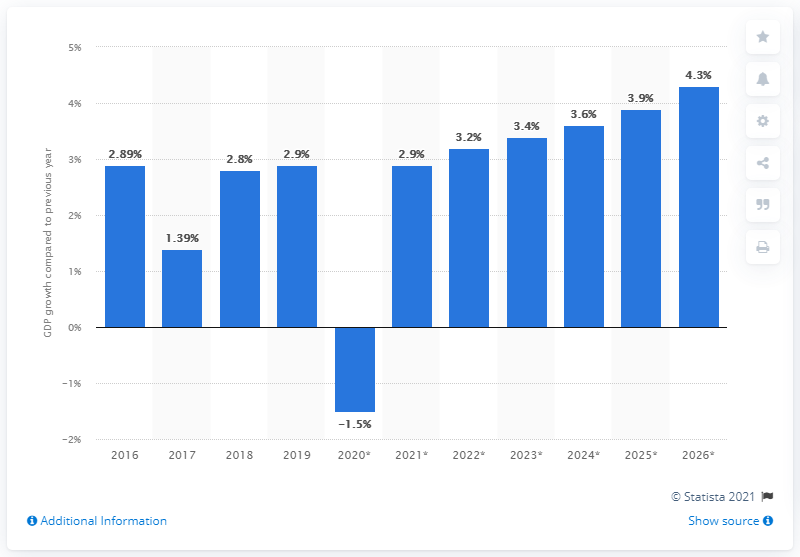Identify some key points in this picture. According to the latest data, Somalia's Gross Domestic Product (GDP) grew by 2.9% in 2019. 